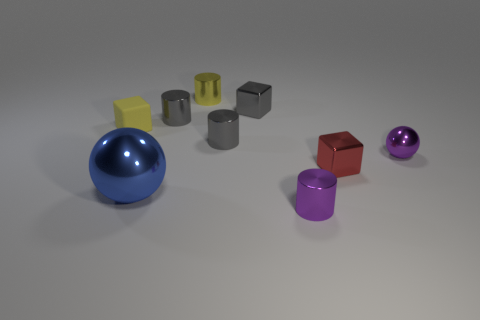Is there any other thing that is the same size as the blue metal ball?
Your answer should be very brief. No. What is the material of the object that is left of the blue object?
Ensure brevity in your answer.  Rubber. There is a yellow object that is the same shape as the tiny red object; what is its material?
Make the answer very short. Rubber. Is there a purple metallic object on the right side of the small metallic cube that is in front of the small gray metal block?
Your answer should be compact. Yes. Is the small yellow metal object the same shape as the yellow rubber object?
Offer a very short reply. No. What shape is the tiny yellow thing that is made of the same material as the big object?
Offer a terse response. Cylinder. There is a gray cylinder that is in front of the rubber cube; is its size the same as the sphere that is right of the tiny red metal cube?
Keep it short and to the point. Yes. Are there more spheres in front of the yellow cube than small red things that are behind the small yellow metallic thing?
Give a very brief answer. Yes. What number of other objects are the same color as the tiny matte block?
Your answer should be compact. 1. There is a big sphere; does it have the same color as the small metallic block in front of the small yellow block?
Ensure brevity in your answer.  No. 